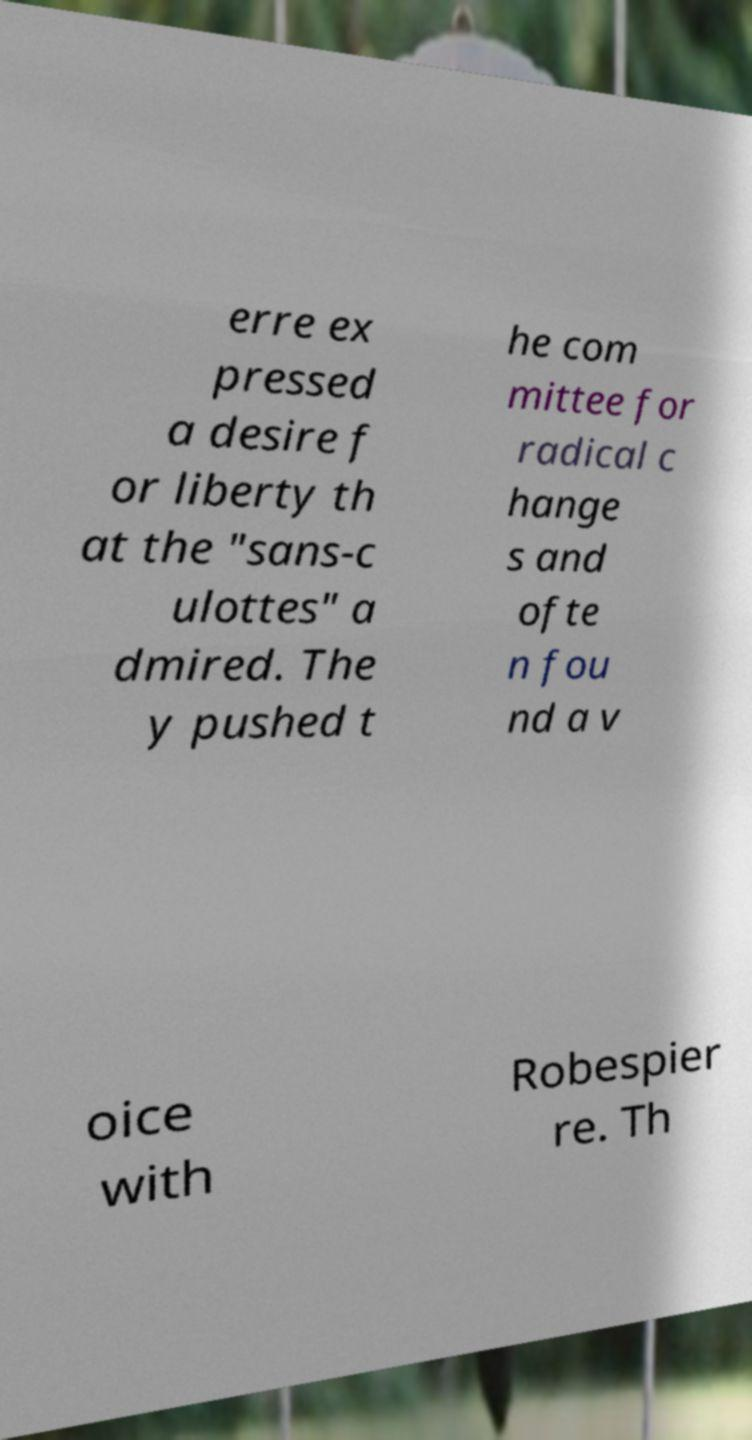What messages or text are displayed in this image? I need them in a readable, typed format. erre ex pressed a desire f or liberty th at the "sans-c ulottes" a dmired. The y pushed t he com mittee for radical c hange s and ofte n fou nd a v oice with Robespier re. Th 